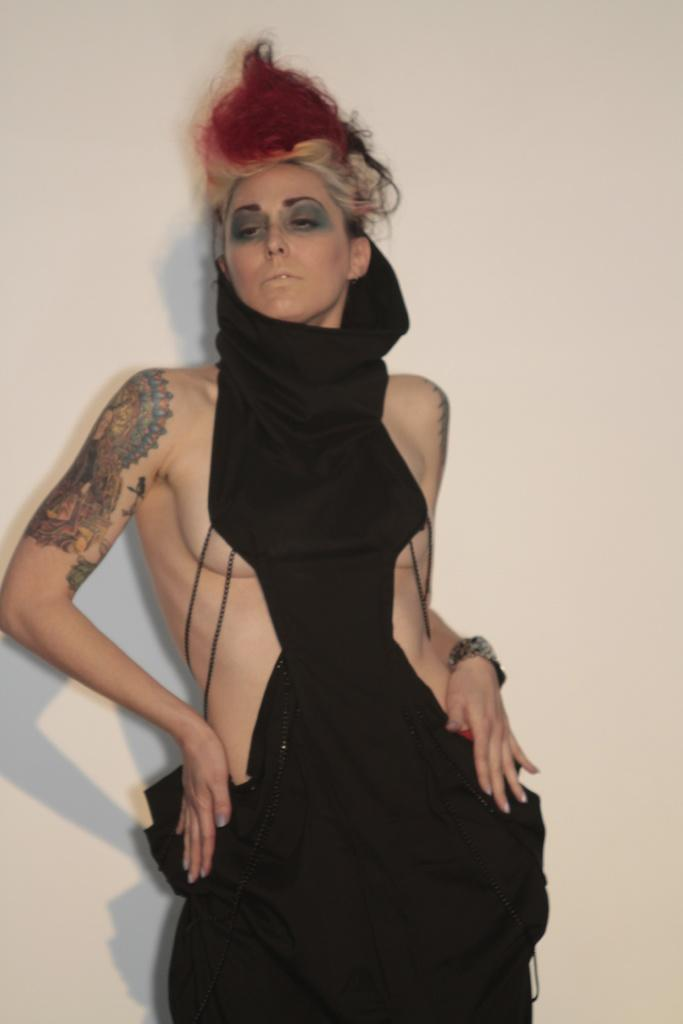Who is present in the image? There is a woman in the image. What is the woman doing in the image? The woman is standing. What can be seen in the background of the image? There is a wall in the background of the image. What type of writing can be seen on the wall in the image? There is no writing visible on the wall in the image. 